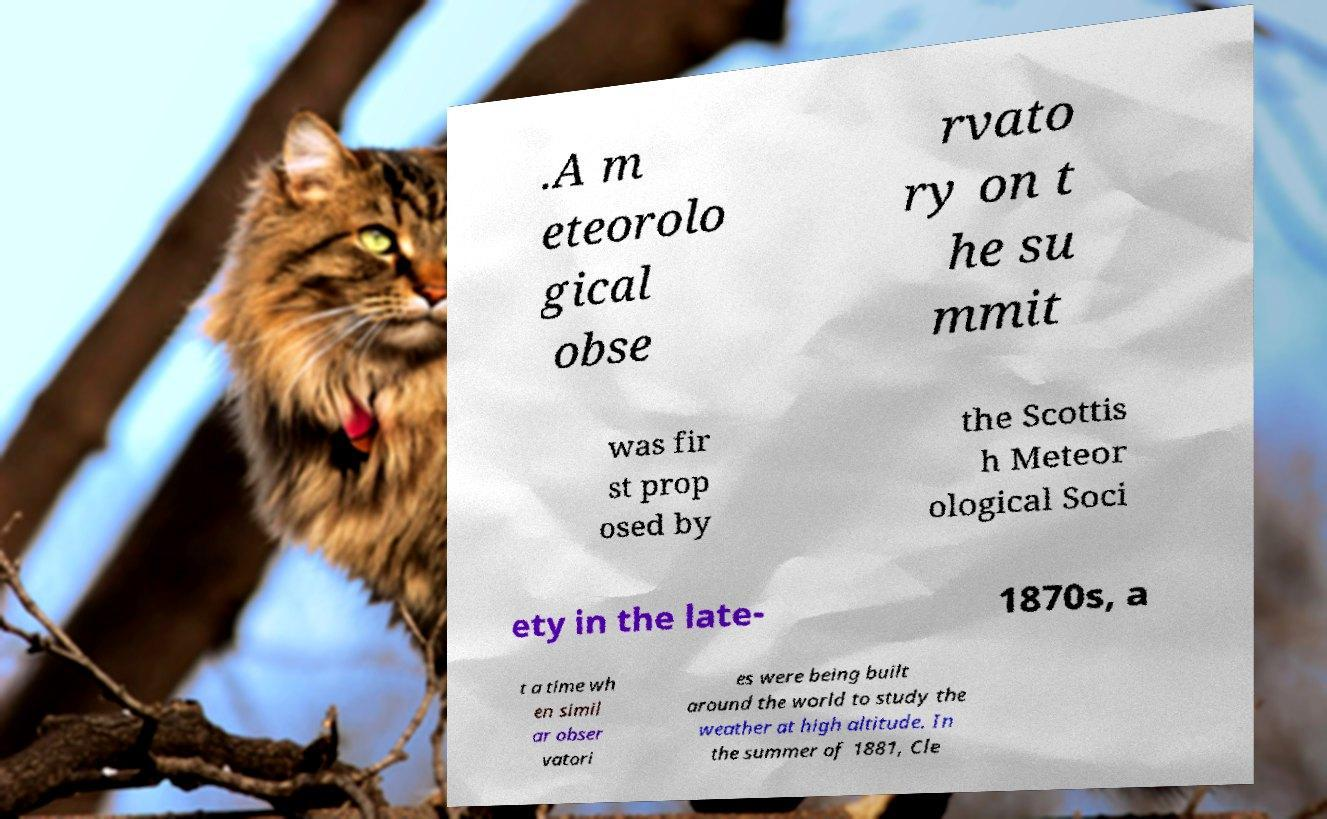What messages or text are displayed in this image? I need them in a readable, typed format. .A m eteorolo gical obse rvato ry on t he su mmit was fir st prop osed by the Scottis h Meteor ological Soci ety in the late- 1870s, a t a time wh en simil ar obser vatori es were being built around the world to study the weather at high altitude. In the summer of 1881, Cle 